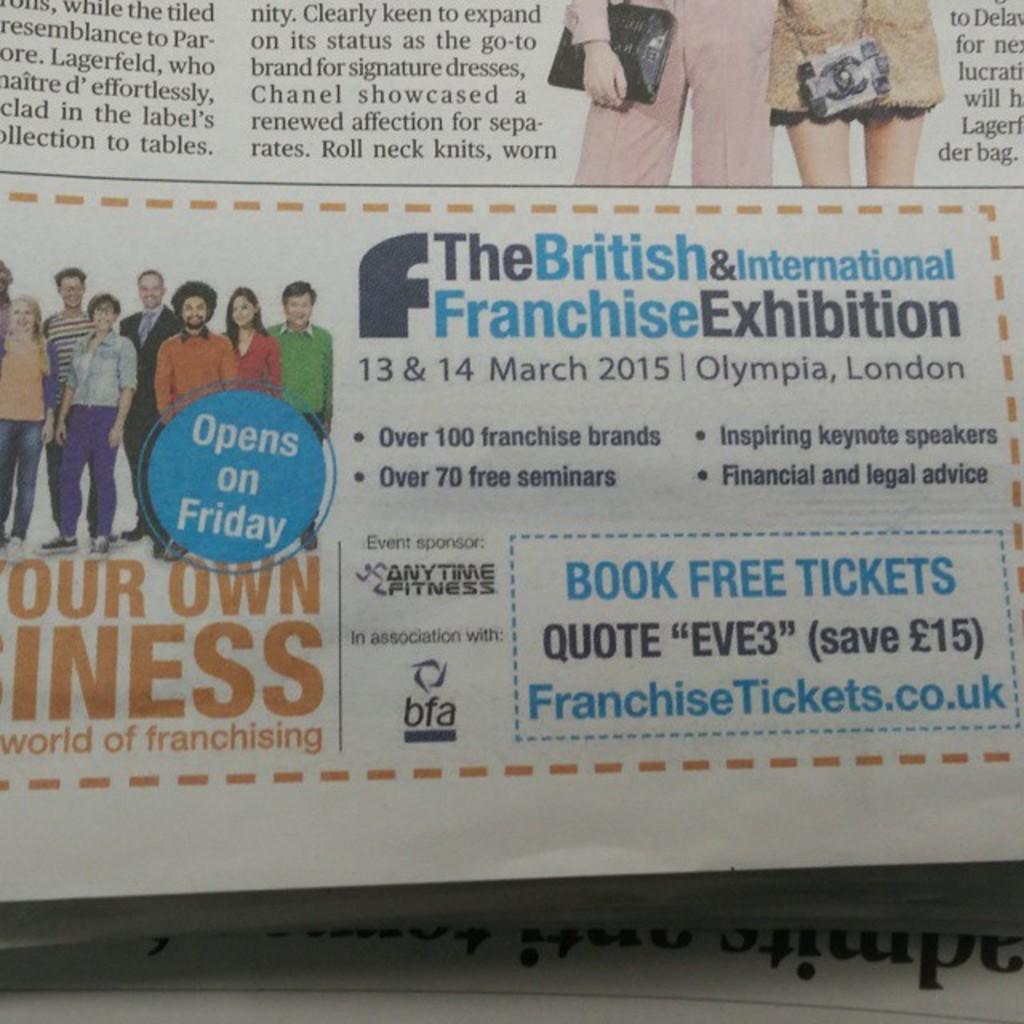In one or two sentences, can you explain what this image depicts? In this picture we can observe an advertisement of an exhibition in the news paper. We can observe some text which is in blue and black color. We can observe some people in the news paper. 